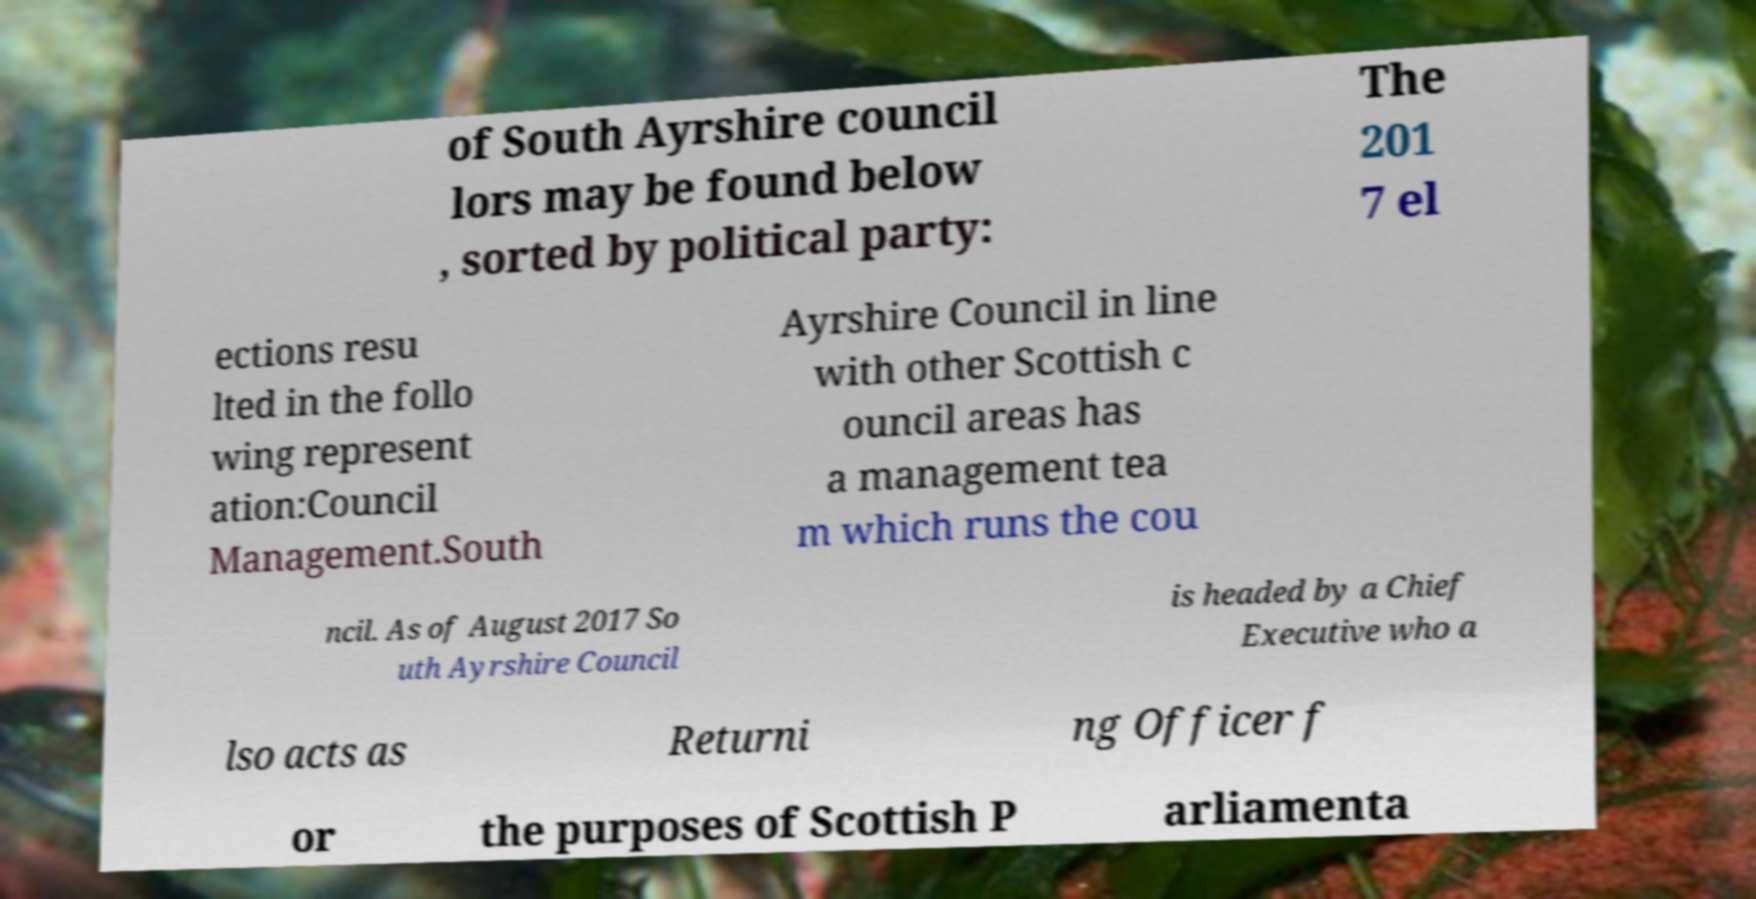Could you extract and type out the text from this image? of South Ayrshire council lors may be found below , sorted by political party: The 201 7 el ections resu lted in the follo wing represent ation:Council Management.South Ayrshire Council in line with other Scottish c ouncil areas has a management tea m which runs the cou ncil. As of August 2017 So uth Ayrshire Council is headed by a Chief Executive who a lso acts as Returni ng Officer f or the purposes of Scottish P arliamenta 